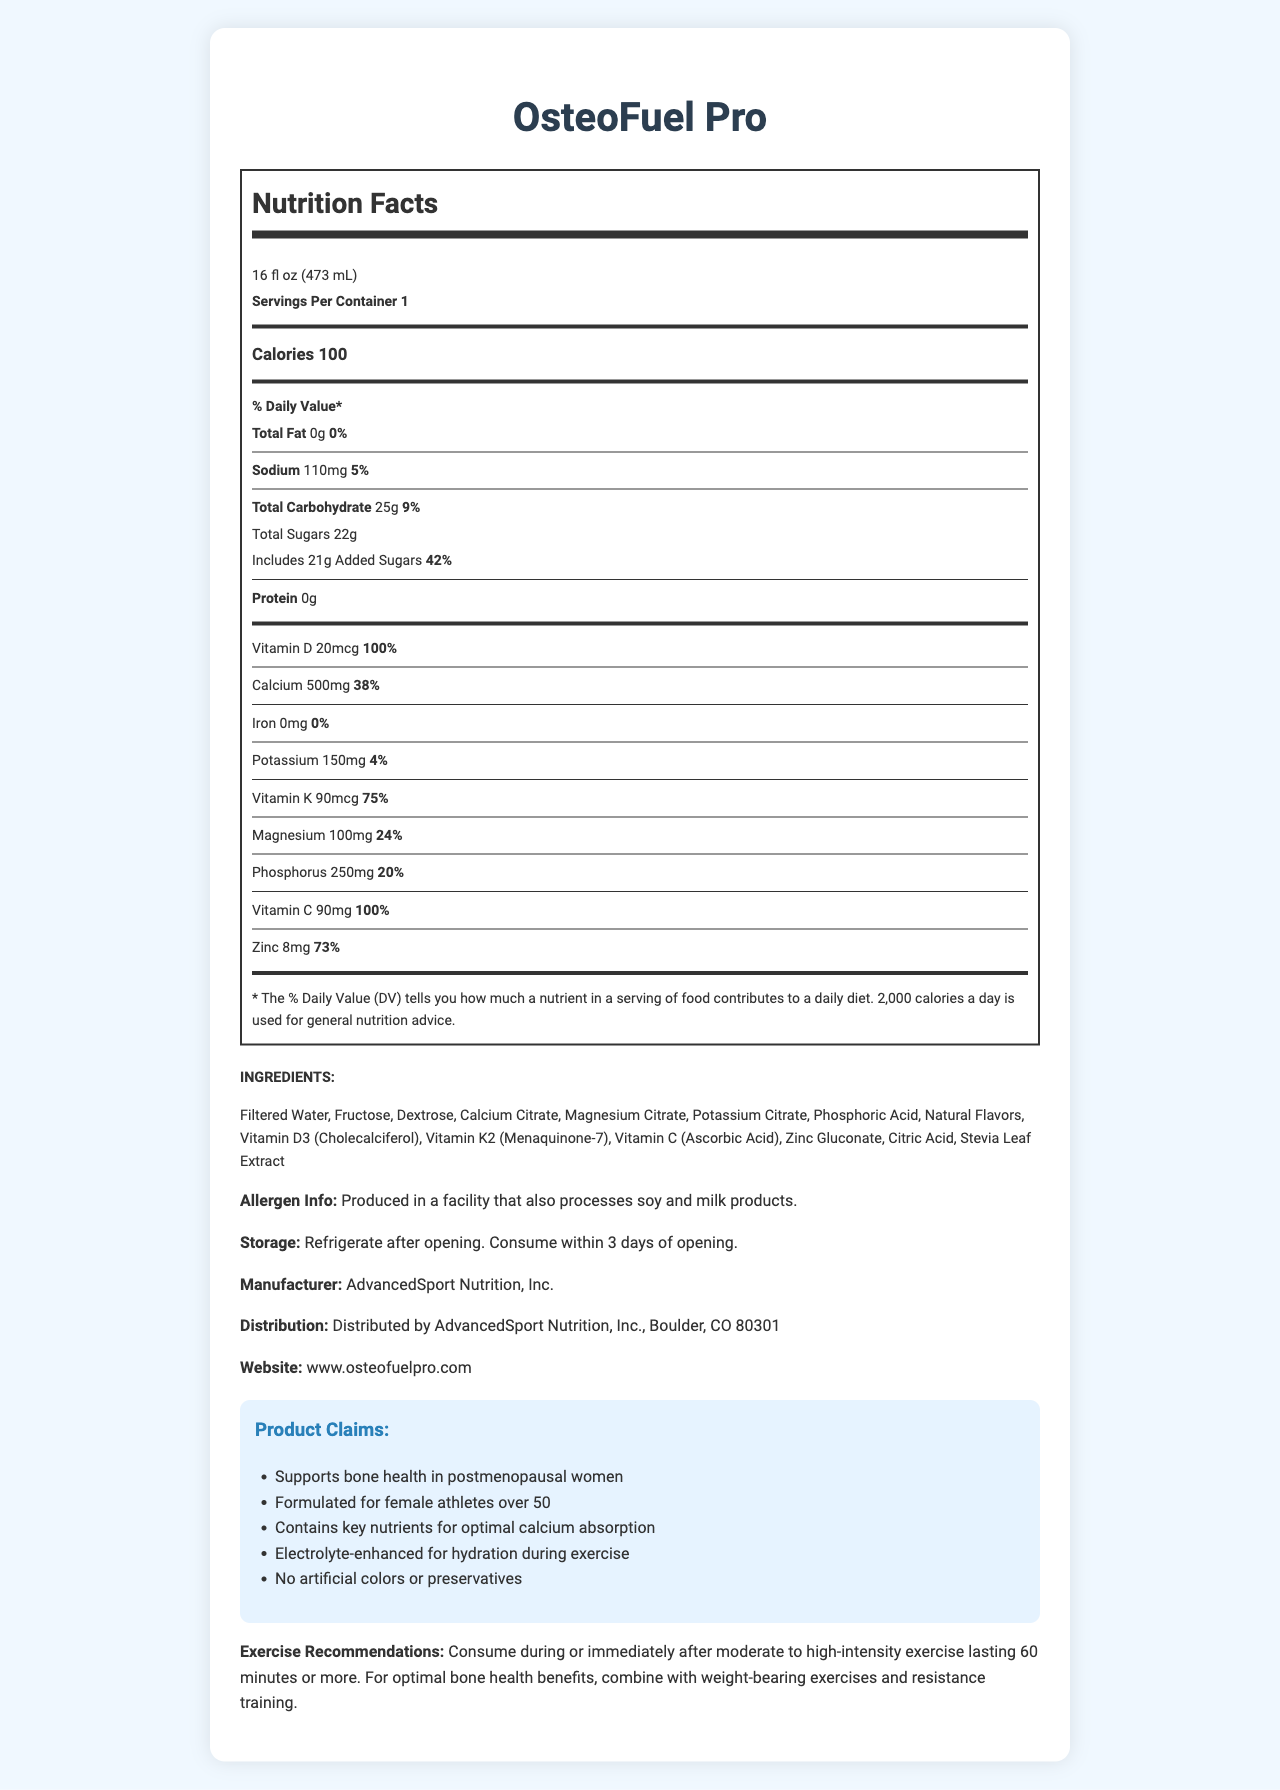what is the serving size for OsteoFuel Pro? The serving size is mentioned in the document as "16 fl oz (473 mL)".
Answer: 16 fl oz (473 mL) how many calories are in one serving of OsteoFuel Pro? The document states that there are 100 calories per serving.
Answer: 100 calories what percentage of the daily value of vitamin D is provided by one serving? It is clearly mentioned in the document that one serving provides 100% of the daily value for vitamin D.
Answer: 100% how much sodium does one serving of OsteoFuel Pro contain? The amount of sodium per serving is listed as 110mg in the document.
Answer: 110mg how many grams of total carbohydrates are in one serving? The total carbohydrate content per serving is 25g as mentioned in the document.
Answer: 25g Is OsteoFuel Pro suitable for someone with a milk allergy? The allergen information states that the product is produced in a facility that also processes milk products.
Answer: No Does OsteoFuel Pro contain any protein? The document specifies that the amount of protein is 0g.
Answer: No which vitamins are included in OsteoFuel Pro? A. Vitamin A, Vitamin D, Vitamin K B. Vitamin B12, Vitamin C, Vitamin K C. Vitamin D, Vitamin K, Vitamin C The document lists Vitamin D, Vitamin K, and Vitamin C among the nutrients included.
Answer: C. Vitamin D, Vitamin K, Vitamin C which of the following ingredients are not present in OsteoFuel Pro? I. Fructose II. Aspartame III. Stevia Leaf Extract IV. Potassium Citrate The list of ingredients includes Fructose, Stevia Leaf Extract, and Potassium Citrate but does not mention Aspartame.
Answer: II. Aspartame Can the nutrient information in the document suffice for someone looking to increase their iron intake? The document indicates that OsteoFuel Pro contains 0mg of iron.
Answer: No Summarize the main idea of the document The document focuses on providing complete nutrition facts and product details for OsteoFuel Pro, emphasizing its formulation for bone health and suitability for female athletes over 50.
Answer: The document provides detailed nutritional information for OsteoFuel Pro, a vitamin-fortified sports drink aimed at supporting bone health in postmenopausal female athletes. It includes details on serving size, calorie content, nutrient percentages, ingredients, allergen information, and product claims about its benefits for bone health and exercise support. Is there enough information in the document to determine if OsteoFuel Pro is gluten-free? The document does not provide any information regarding whether the product is gluten-free.
Answer: Not enough information 